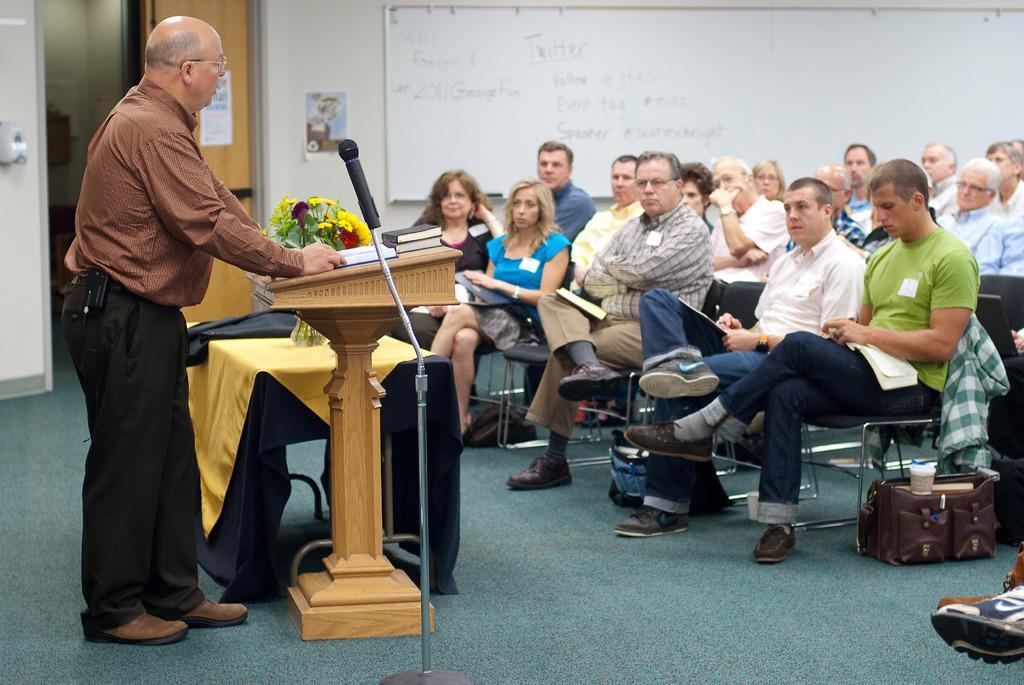Could you give a brief overview of what you see in this image? In the picture I can see people among them one man is standing in front of a podium and others are sitting on chairs. On the podium I can see books. Here I can see a microphone and a table which is covered with a cloth and has flowers on it. In the background I can see a board attached to the wall and some other objects on the floor. 